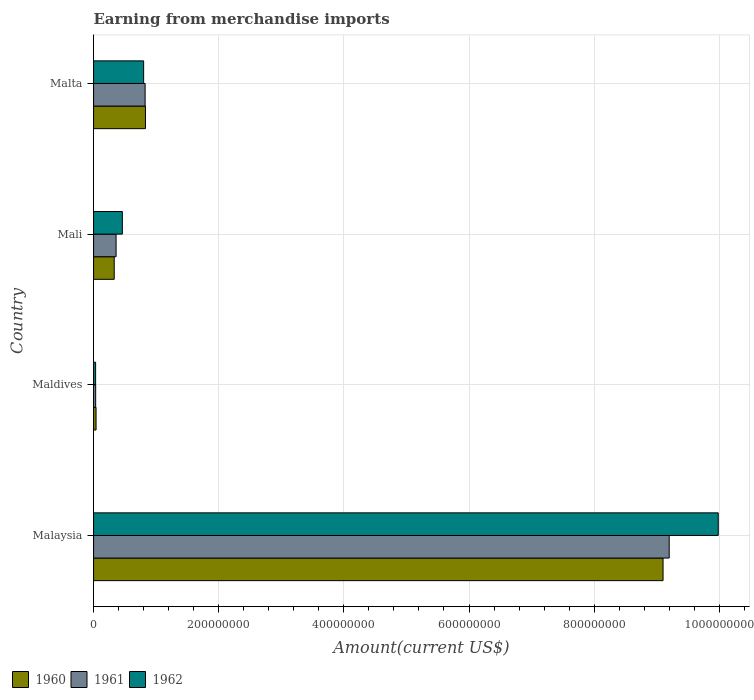How many groups of bars are there?
Offer a terse response. 4. Are the number of bars on each tick of the Y-axis equal?
Offer a very short reply. Yes. How many bars are there on the 1st tick from the bottom?
Offer a very short reply. 3. What is the label of the 1st group of bars from the top?
Make the answer very short. Malta. In how many cases, is the number of bars for a given country not equal to the number of legend labels?
Provide a succinct answer. 0. What is the amount earned from merchandise imports in 1960 in Malaysia?
Offer a terse response. 9.10e+08. Across all countries, what is the maximum amount earned from merchandise imports in 1960?
Offer a very short reply. 9.10e+08. Across all countries, what is the minimum amount earned from merchandise imports in 1960?
Offer a very short reply. 4.00e+06. In which country was the amount earned from merchandise imports in 1961 maximum?
Offer a very short reply. Malaysia. In which country was the amount earned from merchandise imports in 1962 minimum?
Your answer should be very brief. Maldives. What is the total amount earned from merchandise imports in 1960 in the graph?
Give a very brief answer. 1.03e+09. What is the difference between the amount earned from merchandise imports in 1960 in Maldives and that in Mali?
Make the answer very short. -2.90e+07. What is the difference between the amount earned from merchandise imports in 1962 in Malaysia and the amount earned from merchandise imports in 1960 in Malta?
Offer a terse response. 9.15e+08. What is the average amount earned from merchandise imports in 1961 per country?
Offer a very short reply. 2.60e+08. What is the difference between the amount earned from merchandise imports in 1962 and amount earned from merchandise imports in 1961 in Maldives?
Your response must be concise. -9.90e+04. In how many countries, is the amount earned from merchandise imports in 1960 greater than 80000000 US$?
Your answer should be very brief. 2. What is the ratio of the amount earned from merchandise imports in 1961 in Maldives to that in Malta?
Your answer should be very brief. 0.04. Is the amount earned from merchandise imports in 1961 in Maldives less than that in Malta?
Provide a short and direct response. Yes. Is the difference between the amount earned from merchandise imports in 1962 in Malaysia and Mali greater than the difference between the amount earned from merchandise imports in 1961 in Malaysia and Mali?
Make the answer very short. Yes. What is the difference between the highest and the second highest amount earned from merchandise imports in 1962?
Keep it short and to the point. 9.18e+08. What is the difference between the highest and the lowest amount earned from merchandise imports in 1962?
Make the answer very short. 9.95e+08. In how many countries, is the amount earned from merchandise imports in 1960 greater than the average amount earned from merchandise imports in 1960 taken over all countries?
Give a very brief answer. 1. What does the 1st bar from the bottom in Maldives represents?
Offer a very short reply. 1960. How many bars are there?
Keep it short and to the point. 12. Are all the bars in the graph horizontal?
Make the answer very short. Yes. How many countries are there in the graph?
Ensure brevity in your answer.  4. What is the difference between two consecutive major ticks on the X-axis?
Ensure brevity in your answer.  2.00e+08. Does the graph contain grids?
Your answer should be very brief. Yes. How many legend labels are there?
Give a very brief answer. 3. How are the legend labels stacked?
Your response must be concise. Horizontal. What is the title of the graph?
Your answer should be compact. Earning from merchandise imports. What is the label or title of the X-axis?
Your answer should be compact. Amount(current US$). What is the Amount(current US$) in 1960 in Malaysia?
Provide a succinct answer. 9.10e+08. What is the Amount(current US$) in 1961 in Malaysia?
Your response must be concise. 9.20e+08. What is the Amount(current US$) in 1962 in Malaysia?
Provide a short and direct response. 9.98e+08. What is the Amount(current US$) of 1961 in Maldives?
Provide a succinct answer. 3.37e+06. What is the Amount(current US$) of 1962 in Maldives?
Provide a succinct answer. 3.27e+06. What is the Amount(current US$) of 1960 in Mali?
Keep it short and to the point. 3.30e+07. What is the Amount(current US$) in 1961 in Mali?
Your response must be concise. 3.60e+07. What is the Amount(current US$) in 1962 in Mali?
Make the answer very short. 4.60e+07. What is the Amount(current US$) of 1960 in Malta?
Make the answer very short. 8.29e+07. What is the Amount(current US$) of 1961 in Malta?
Ensure brevity in your answer.  8.24e+07. What is the Amount(current US$) of 1962 in Malta?
Ensure brevity in your answer.  8.00e+07. Across all countries, what is the maximum Amount(current US$) of 1960?
Make the answer very short. 9.10e+08. Across all countries, what is the maximum Amount(current US$) in 1961?
Provide a short and direct response. 9.20e+08. Across all countries, what is the maximum Amount(current US$) of 1962?
Your response must be concise. 9.98e+08. Across all countries, what is the minimum Amount(current US$) of 1961?
Give a very brief answer. 3.37e+06. Across all countries, what is the minimum Amount(current US$) in 1962?
Your answer should be very brief. 3.27e+06. What is the total Amount(current US$) of 1960 in the graph?
Your response must be concise. 1.03e+09. What is the total Amount(current US$) of 1961 in the graph?
Provide a succinct answer. 1.04e+09. What is the total Amount(current US$) in 1962 in the graph?
Provide a short and direct response. 1.13e+09. What is the difference between the Amount(current US$) in 1960 in Malaysia and that in Maldives?
Provide a short and direct response. 9.06e+08. What is the difference between the Amount(current US$) in 1961 in Malaysia and that in Maldives?
Your response must be concise. 9.17e+08. What is the difference between the Amount(current US$) of 1962 in Malaysia and that in Maldives?
Give a very brief answer. 9.95e+08. What is the difference between the Amount(current US$) of 1960 in Malaysia and that in Mali?
Your answer should be very brief. 8.77e+08. What is the difference between the Amount(current US$) of 1961 in Malaysia and that in Mali?
Your answer should be very brief. 8.84e+08. What is the difference between the Amount(current US$) in 1962 in Malaysia and that in Mali?
Provide a succinct answer. 9.52e+08. What is the difference between the Amount(current US$) in 1960 in Malaysia and that in Malta?
Your answer should be compact. 8.27e+08. What is the difference between the Amount(current US$) in 1961 in Malaysia and that in Malta?
Offer a terse response. 8.37e+08. What is the difference between the Amount(current US$) of 1962 in Malaysia and that in Malta?
Make the answer very short. 9.18e+08. What is the difference between the Amount(current US$) of 1960 in Maldives and that in Mali?
Make the answer very short. -2.90e+07. What is the difference between the Amount(current US$) of 1961 in Maldives and that in Mali?
Your response must be concise. -3.26e+07. What is the difference between the Amount(current US$) of 1962 in Maldives and that in Mali?
Your response must be concise. -4.27e+07. What is the difference between the Amount(current US$) in 1960 in Maldives and that in Malta?
Provide a short and direct response. -7.89e+07. What is the difference between the Amount(current US$) of 1961 in Maldives and that in Malta?
Provide a short and direct response. -7.90e+07. What is the difference between the Amount(current US$) in 1962 in Maldives and that in Malta?
Provide a short and direct response. -7.67e+07. What is the difference between the Amount(current US$) of 1960 in Mali and that in Malta?
Your response must be concise. -4.99e+07. What is the difference between the Amount(current US$) in 1961 in Mali and that in Malta?
Offer a very short reply. -4.64e+07. What is the difference between the Amount(current US$) in 1962 in Mali and that in Malta?
Your response must be concise. -3.40e+07. What is the difference between the Amount(current US$) of 1960 in Malaysia and the Amount(current US$) of 1961 in Maldives?
Provide a short and direct response. 9.07e+08. What is the difference between the Amount(current US$) of 1960 in Malaysia and the Amount(current US$) of 1962 in Maldives?
Make the answer very short. 9.07e+08. What is the difference between the Amount(current US$) in 1961 in Malaysia and the Amount(current US$) in 1962 in Maldives?
Your answer should be very brief. 9.17e+08. What is the difference between the Amount(current US$) in 1960 in Malaysia and the Amount(current US$) in 1961 in Mali?
Make the answer very short. 8.74e+08. What is the difference between the Amount(current US$) in 1960 in Malaysia and the Amount(current US$) in 1962 in Mali?
Keep it short and to the point. 8.64e+08. What is the difference between the Amount(current US$) in 1961 in Malaysia and the Amount(current US$) in 1962 in Mali?
Make the answer very short. 8.74e+08. What is the difference between the Amount(current US$) in 1960 in Malaysia and the Amount(current US$) in 1961 in Malta?
Offer a terse response. 8.28e+08. What is the difference between the Amount(current US$) of 1960 in Malaysia and the Amount(current US$) of 1962 in Malta?
Give a very brief answer. 8.30e+08. What is the difference between the Amount(current US$) of 1961 in Malaysia and the Amount(current US$) of 1962 in Malta?
Your answer should be compact. 8.40e+08. What is the difference between the Amount(current US$) in 1960 in Maldives and the Amount(current US$) in 1961 in Mali?
Provide a short and direct response. -3.20e+07. What is the difference between the Amount(current US$) in 1960 in Maldives and the Amount(current US$) in 1962 in Mali?
Your answer should be compact. -4.20e+07. What is the difference between the Amount(current US$) in 1961 in Maldives and the Amount(current US$) in 1962 in Mali?
Your answer should be very brief. -4.26e+07. What is the difference between the Amount(current US$) in 1960 in Maldives and the Amount(current US$) in 1961 in Malta?
Ensure brevity in your answer.  -7.84e+07. What is the difference between the Amount(current US$) in 1960 in Maldives and the Amount(current US$) in 1962 in Malta?
Your answer should be compact. -7.60e+07. What is the difference between the Amount(current US$) in 1961 in Maldives and the Amount(current US$) in 1962 in Malta?
Give a very brief answer. -7.66e+07. What is the difference between the Amount(current US$) in 1960 in Mali and the Amount(current US$) in 1961 in Malta?
Make the answer very short. -4.94e+07. What is the difference between the Amount(current US$) in 1960 in Mali and the Amount(current US$) in 1962 in Malta?
Ensure brevity in your answer.  -4.70e+07. What is the difference between the Amount(current US$) in 1961 in Mali and the Amount(current US$) in 1962 in Malta?
Give a very brief answer. -4.40e+07. What is the average Amount(current US$) of 1960 per country?
Ensure brevity in your answer.  2.58e+08. What is the average Amount(current US$) in 1961 per country?
Offer a very short reply. 2.60e+08. What is the average Amount(current US$) in 1962 per country?
Your answer should be compact. 2.82e+08. What is the difference between the Amount(current US$) in 1960 and Amount(current US$) in 1961 in Malaysia?
Your answer should be very brief. -9.80e+06. What is the difference between the Amount(current US$) of 1960 and Amount(current US$) of 1962 in Malaysia?
Give a very brief answer. -8.82e+07. What is the difference between the Amount(current US$) of 1961 and Amount(current US$) of 1962 in Malaysia?
Offer a terse response. -7.84e+07. What is the difference between the Amount(current US$) of 1960 and Amount(current US$) of 1961 in Maldives?
Make the answer very short. 6.34e+05. What is the difference between the Amount(current US$) of 1960 and Amount(current US$) of 1962 in Maldives?
Offer a very short reply. 7.33e+05. What is the difference between the Amount(current US$) of 1961 and Amount(current US$) of 1962 in Maldives?
Your answer should be very brief. 9.90e+04. What is the difference between the Amount(current US$) in 1960 and Amount(current US$) in 1961 in Mali?
Offer a terse response. -3.00e+06. What is the difference between the Amount(current US$) in 1960 and Amount(current US$) in 1962 in Mali?
Give a very brief answer. -1.30e+07. What is the difference between the Amount(current US$) in 1961 and Amount(current US$) in 1962 in Mali?
Give a very brief answer. -1.00e+07. What is the difference between the Amount(current US$) of 1960 and Amount(current US$) of 1961 in Malta?
Your response must be concise. 5.29e+05. What is the difference between the Amount(current US$) in 1960 and Amount(current US$) in 1962 in Malta?
Your answer should be compact. 2.91e+06. What is the difference between the Amount(current US$) of 1961 and Amount(current US$) of 1962 in Malta?
Give a very brief answer. 2.38e+06. What is the ratio of the Amount(current US$) in 1960 in Malaysia to that in Maldives?
Offer a terse response. 227.52. What is the ratio of the Amount(current US$) of 1961 in Malaysia to that in Maldives?
Your answer should be very brief. 273.29. What is the ratio of the Amount(current US$) of 1962 in Malaysia to that in Maldives?
Keep it short and to the point. 305.57. What is the ratio of the Amount(current US$) in 1960 in Malaysia to that in Mali?
Your response must be concise. 27.58. What is the ratio of the Amount(current US$) in 1961 in Malaysia to that in Mali?
Offer a terse response. 25.55. What is the ratio of the Amount(current US$) in 1962 in Malaysia to that in Mali?
Provide a short and direct response. 21.7. What is the ratio of the Amount(current US$) of 1960 in Malaysia to that in Malta?
Offer a very short reply. 10.97. What is the ratio of the Amount(current US$) in 1961 in Malaysia to that in Malta?
Your answer should be compact. 11.16. What is the ratio of the Amount(current US$) of 1962 in Malaysia to that in Malta?
Your answer should be very brief. 12.48. What is the ratio of the Amount(current US$) of 1960 in Maldives to that in Mali?
Give a very brief answer. 0.12. What is the ratio of the Amount(current US$) of 1961 in Maldives to that in Mali?
Your answer should be compact. 0.09. What is the ratio of the Amount(current US$) in 1962 in Maldives to that in Mali?
Keep it short and to the point. 0.07. What is the ratio of the Amount(current US$) of 1960 in Maldives to that in Malta?
Provide a succinct answer. 0.05. What is the ratio of the Amount(current US$) of 1961 in Maldives to that in Malta?
Provide a succinct answer. 0.04. What is the ratio of the Amount(current US$) in 1962 in Maldives to that in Malta?
Keep it short and to the point. 0.04. What is the ratio of the Amount(current US$) in 1960 in Mali to that in Malta?
Your answer should be very brief. 0.4. What is the ratio of the Amount(current US$) in 1961 in Mali to that in Malta?
Give a very brief answer. 0.44. What is the ratio of the Amount(current US$) of 1962 in Mali to that in Malta?
Give a very brief answer. 0.57. What is the difference between the highest and the second highest Amount(current US$) in 1960?
Your response must be concise. 8.27e+08. What is the difference between the highest and the second highest Amount(current US$) of 1961?
Give a very brief answer. 8.37e+08. What is the difference between the highest and the second highest Amount(current US$) in 1962?
Give a very brief answer. 9.18e+08. What is the difference between the highest and the lowest Amount(current US$) in 1960?
Make the answer very short. 9.06e+08. What is the difference between the highest and the lowest Amount(current US$) in 1961?
Offer a very short reply. 9.17e+08. What is the difference between the highest and the lowest Amount(current US$) of 1962?
Offer a terse response. 9.95e+08. 